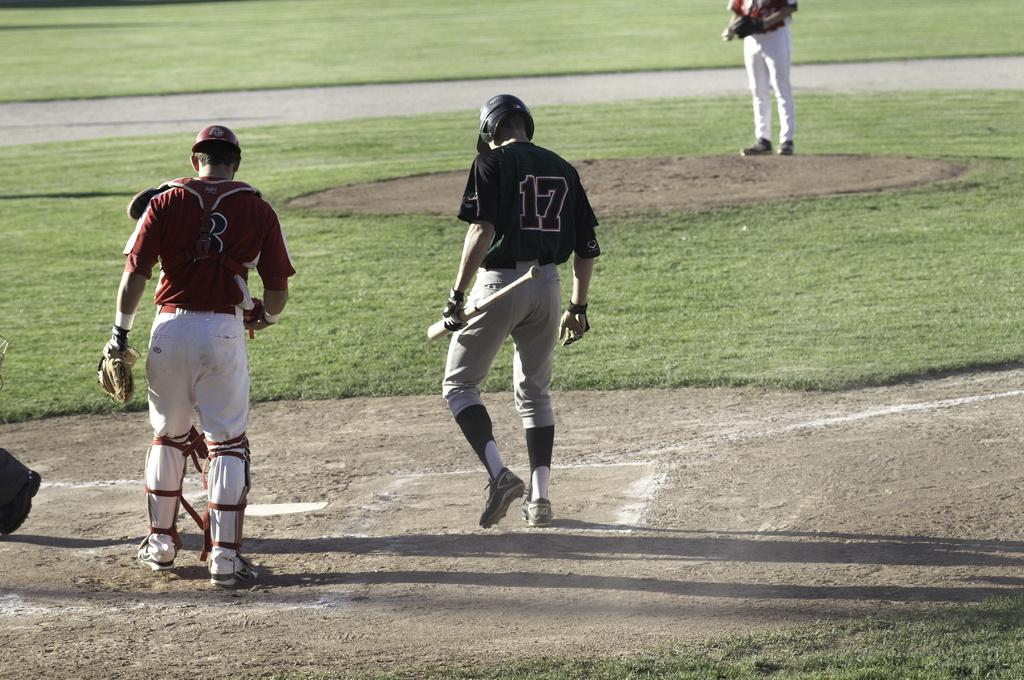<image>
Relay a brief, clear account of the picture shown. a player that has the number 17 on his baseball jersey 